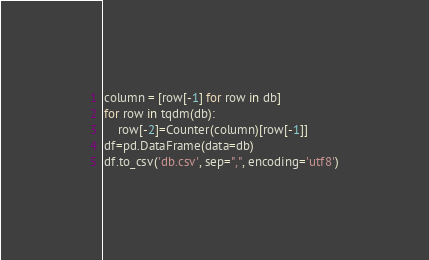<code> <loc_0><loc_0><loc_500><loc_500><_Python_>column = [row[-1] for row in db]
for row in tqdm(db):
    row[-2]=Counter(column)[row[-1]]
df=pd.DataFrame(data=db)
df.to_csv('db.csv', sep=",", encoding='utf8')</code> 